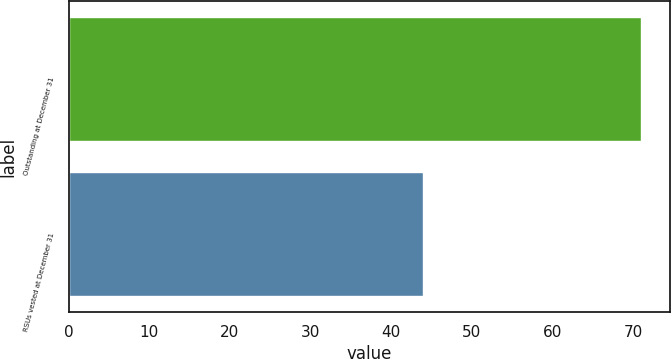Convert chart. <chart><loc_0><loc_0><loc_500><loc_500><bar_chart><fcel>Outstanding at December 31<fcel>RSUs vested at December 31<nl><fcel>71<fcel>44<nl></chart> 